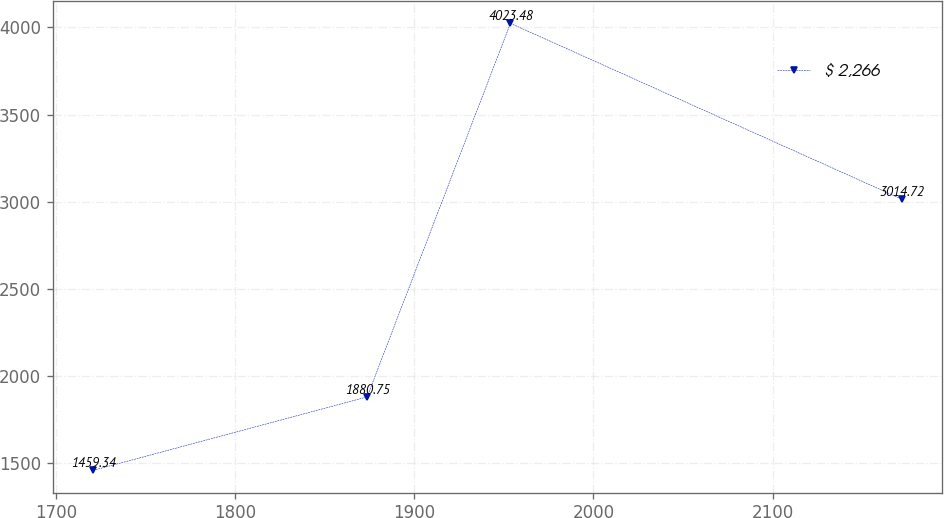Convert chart to OTSL. <chart><loc_0><loc_0><loc_500><loc_500><line_chart><ecel><fcel>$ 2,266<nl><fcel>1720.82<fcel>1459.34<nl><fcel>1873.73<fcel>1880.75<nl><fcel>1953.71<fcel>4023.48<nl><fcel>2172.24<fcel>3014.72<nl></chart> 